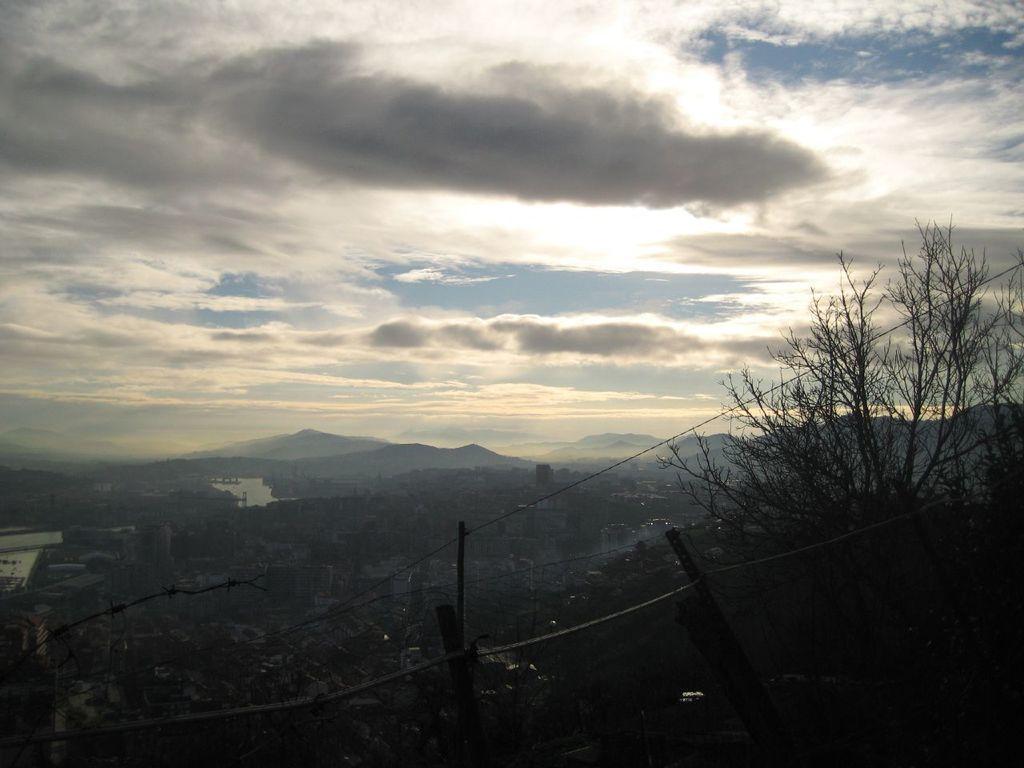Can you describe this image briefly? In this image there are trees, buildings, hills, and in the background there is sky. 